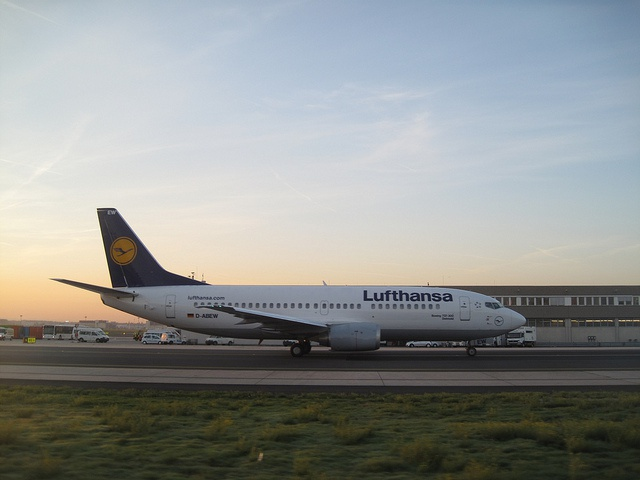Describe the objects in this image and their specific colors. I can see airplane in lightgray, black, and gray tones, truck in lightgray, gray, and black tones, bus in lightgray, gray, and black tones, car in lightgray, gray, black, and maroon tones, and car in lightgray, gray, and black tones in this image. 